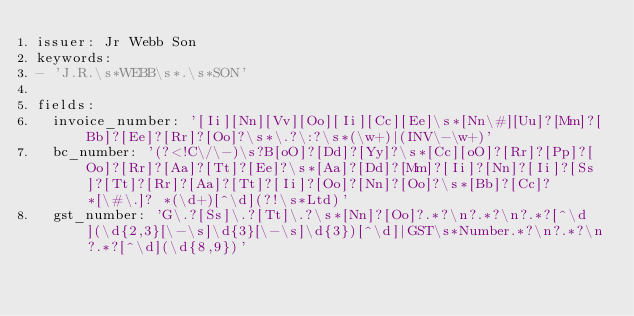Convert code to text. <code><loc_0><loc_0><loc_500><loc_500><_YAML_>issuer: Jr Webb Son
keywords:
- 'J.R.\s*WEBB\s*.\s*SON'

fields:
  invoice_number: '[Ii][Nn][Vv][Oo][Ii][Cc][Ee]\s*[Nn\#][Uu]?[Mm]?[Bb]?[Ee]?[Rr]?[Oo]?\s*\.?\:?\s*(\w+)|(INV\-\w+)'
  bc_number: '(?<!C\/\-)\s?B[oO]?[Dd]?[Yy]?\s*[Cc][oO]?[Rr]?[Pp]?[Oo]?[Rr]?[Aa]?[Tt]?[Ee]?\s*[Aa]?[Dd]?[Mm]?[Ii]?[Nn]?[Ii]?[Ss]?[Tt]?[Rr]?[Aa]?[Tt]?[Ii]?[Oo]?[Nn]?[Oo]?\s*[Bb]?[Cc]? *[\#\.]? *(\d+)[^\d](?!\s*Ltd)'
  gst_number: 'G\.?[Ss]\.?[Tt]\.?\s*[Nn]?[Oo]?.*?\n?.*?\n?.*?[^\d](\d{2,3}[\-\s]\d{3}[\-\s]\d{3})[^\d]|GST\s*Number.*?\n?.*?\n?.*?[^\d](\d{8,9})'</code> 